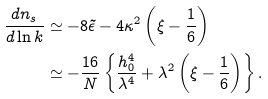Convert formula to latex. <formula><loc_0><loc_0><loc_500><loc_500>\frac { d n _ { s } } { d \ln k } & \simeq - 8 \tilde { \epsilon } - 4 \kappa ^ { 2 } \left ( \xi - \frac { 1 } { 6 } \right ) \\ & \simeq - \frac { 1 6 } { N } \left \{ \frac { h _ { 0 } ^ { 4 } } { \lambda ^ { 4 } } + \lambda ^ { 2 } \left ( \xi - \frac { 1 } { 6 } \right ) \right \} .</formula> 